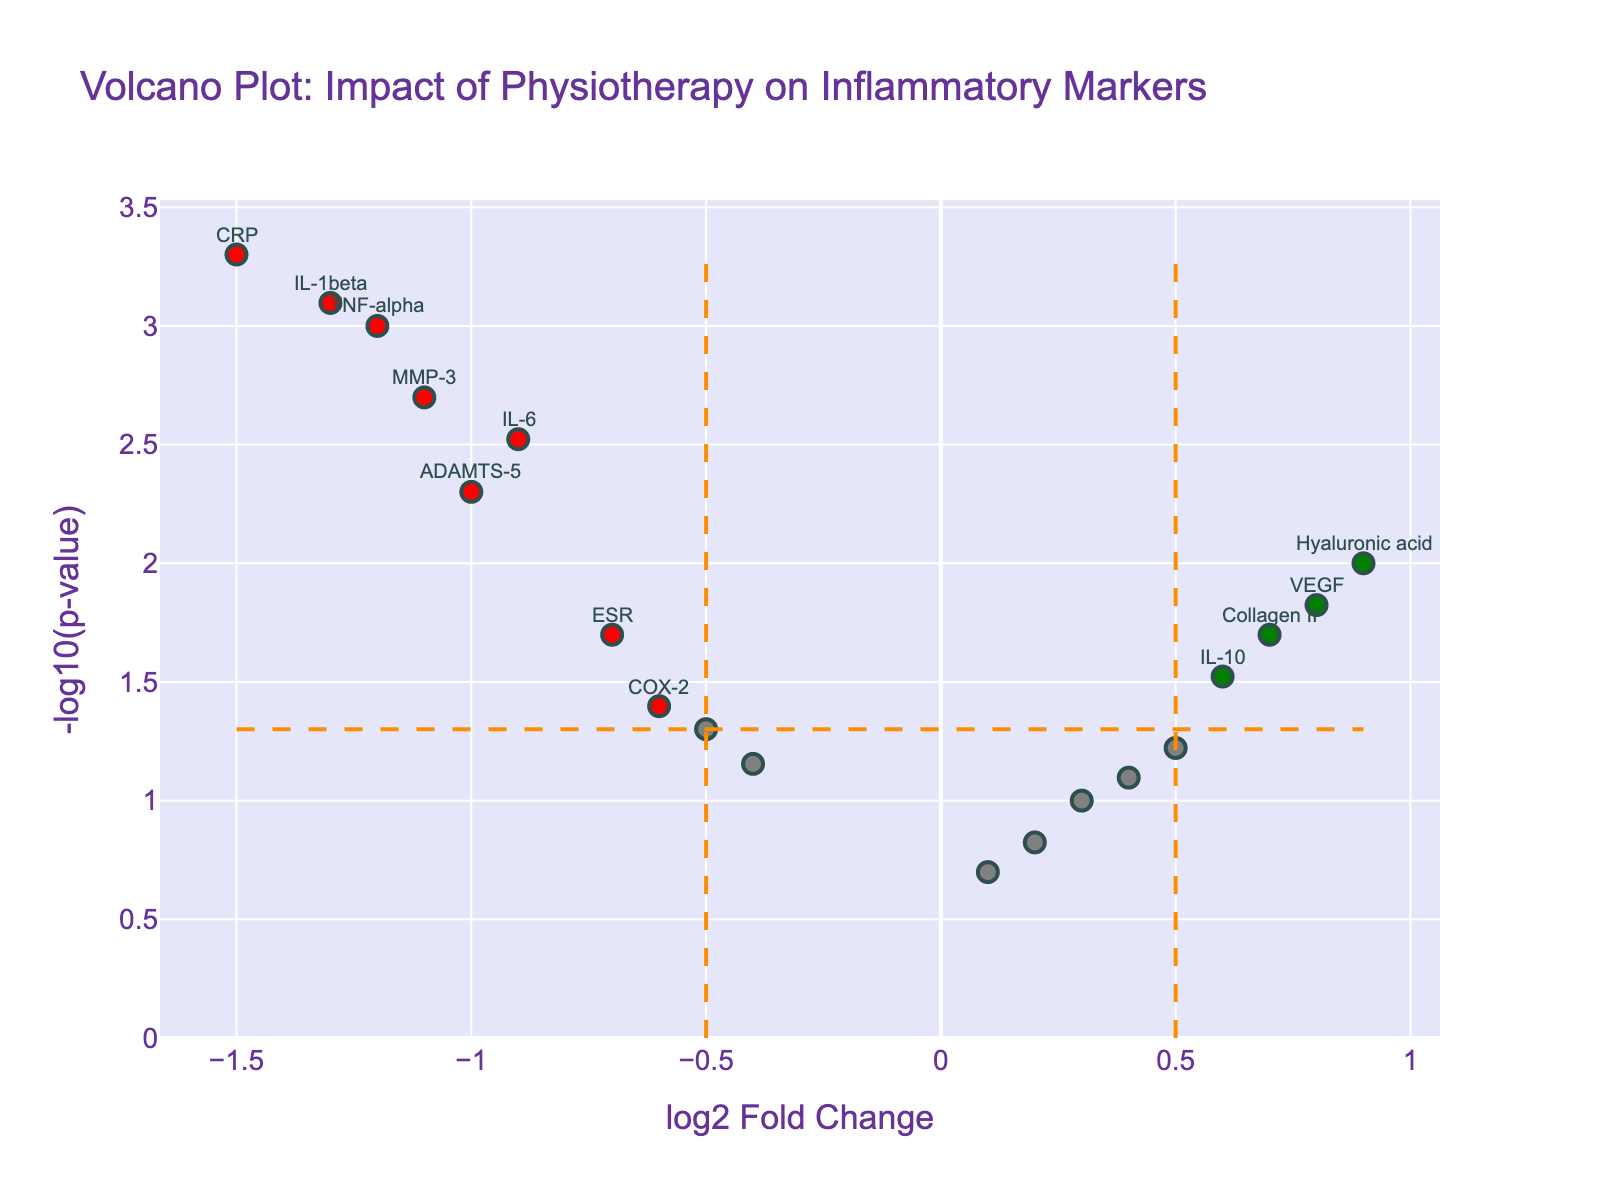What is the title of the Volcano Plot? The title is displayed at the top of the figure, indicating what the plot represents.
Answer: Volcano Plot: Impact of Physiotherapy on Inflammatory Markers How many data points are shown in the Volcano Plot? Count the number of markers on the plot. Each marker represents a data point.
Answer: 18 What do the green and red colors on the plot signify? Green and red colors represent genes that are significantly different. Green indicates a positive log2 Fold Change and red a negative log2 Fold Change with significant p-values.
Answer: Significant positive and negative changes Which gene has the highest log2 Fold Change? Identify the marker farthest to the right on the plot.
Answer: Hyaluronic acid What is the p-value threshold used for significance in this plot? The horizontal dashed line represents the p-value threshold, with its y-axis value being -log10(0.05).
Answer: 0.05 Name two genes that are not significantly affected by physiotherapy (grey points). Identify markers that are grey and not highlighted.
Answer: NF-kB, BMP-7 How many genes have a log2 Fold Change greater than 0.5? Count the number of markers to the right of the vertical dashed line at 0.5 log2 Fold Change.
Answer: 5 Which gene has the lowest -log10(p-value)? Identify the data point lowest on the y-axis of the plot.
Answer: IGF-1 Compare the log2 Fold Change of IL-1beta with ADAMTS-5. Which one is lower? Check the x-axis positions of IL-1beta and ADAMTS-5 and compare.
Answer: IL-1beta How many genes have both a log2 Fold Change greater than 0.5 and a p-value less than 0.05? Count the number of markers that are green in color.
Answer: 2 